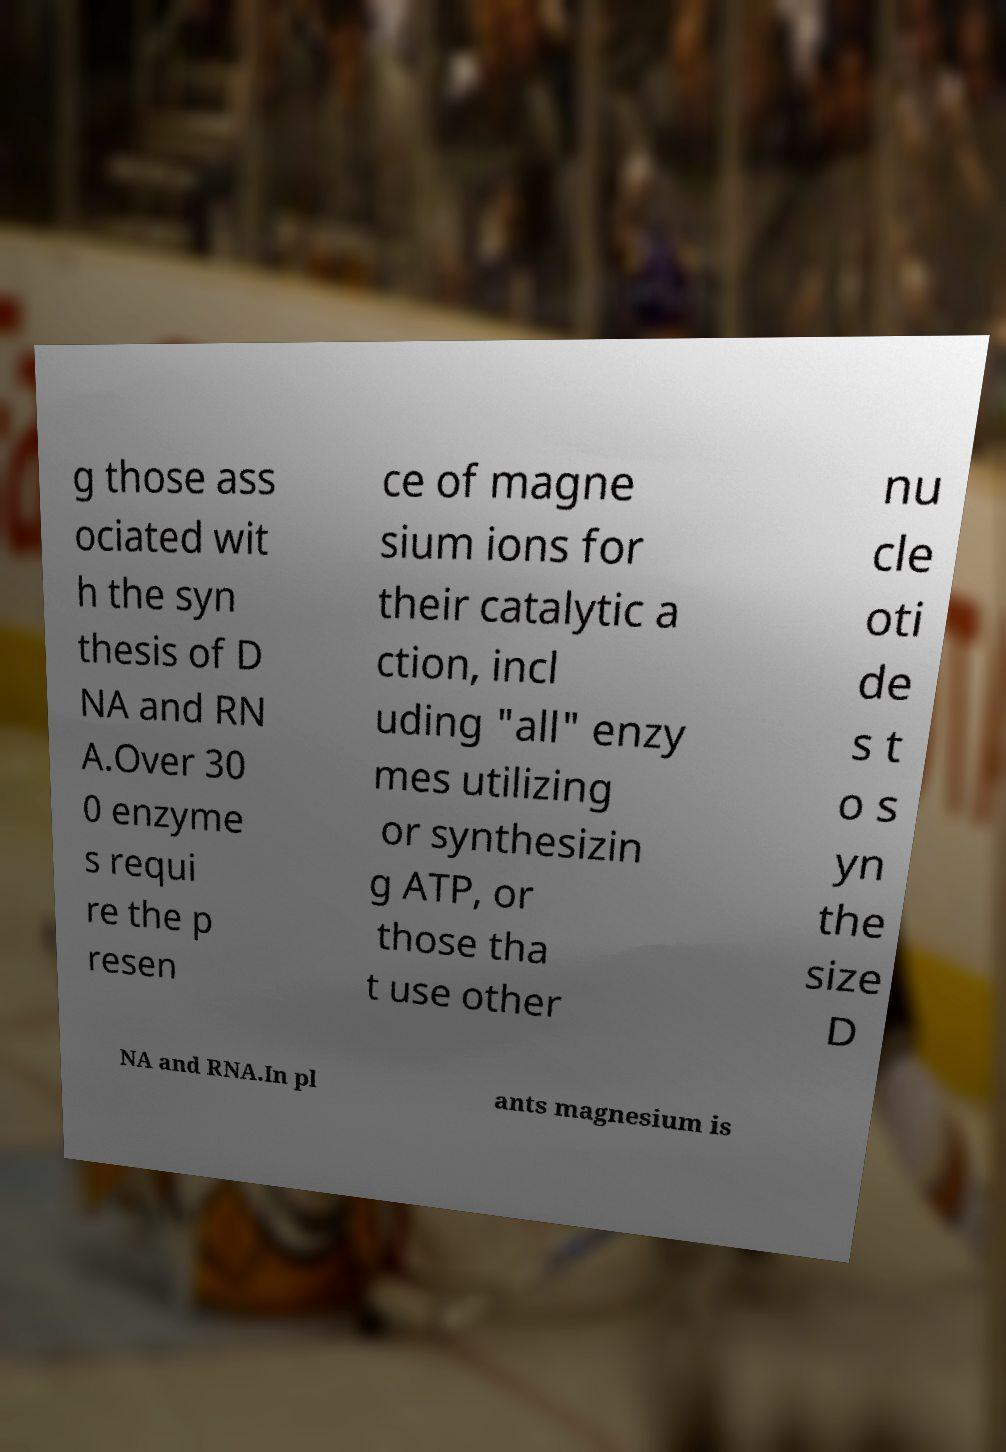For documentation purposes, I need the text within this image transcribed. Could you provide that? g those ass ociated wit h the syn thesis of D NA and RN A.Over 30 0 enzyme s requi re the p resen ce of magne sium ions for their catalytic a ction, incl uding "all" enzy mes utilizing or synthesizin g ATP, or those tha t use other nu cle oti de s t o s yn the size D NA and RNA.In pl ants magnesium is 